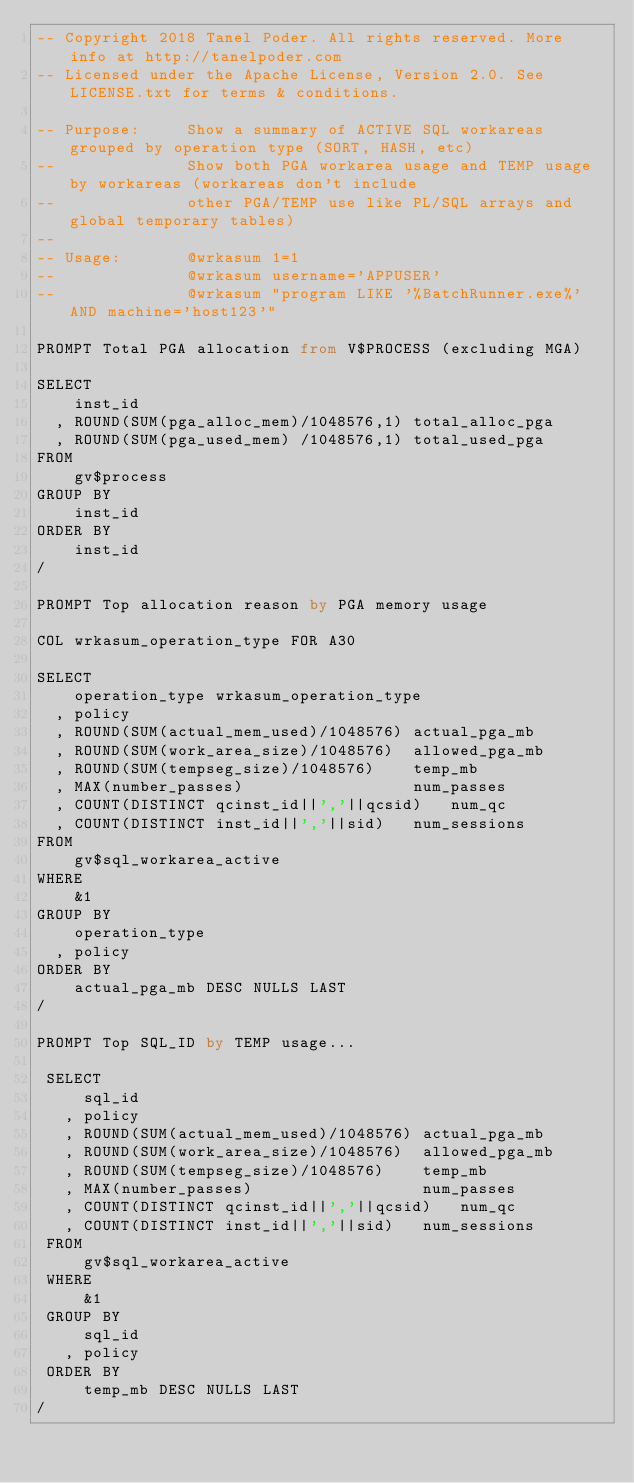Convert code to text. <code><loc_0><loc_0><loc_500><loc_500><_SQL_>-- Copyright 2018 Tanel Poder. All rights reserved. More info at http://tanelpoder.com
-- Licensed under the Apache License, Version 2.0. See LICENSE.txt for terms & conditions.

-- Purpose:     Show a summary of ACTIVE SQL workareas grouped by operation type (SORT, HASH, etc)
--              Show both PGA workarea usage and TEMP usage by workareas (workareas don't include
--              other PGA/TEMP use like PL/SQL arrays and global temporary tables)
--
-- Usage:       @wrkasum 1=1 
--              @wrkasum username='APPUSER'
--              @wrkasum "program LIKE '%BatchRunner.exe%' AND machine='host123'"

PROMPT Total PGA allocation from V$PROCESS (excluding MGA)

SELECT 
    inst_id
  , ROUND(SUM(pga_alloc_mem)/1048576,1) total_alloc_pga
  , ROUND(SUM(pga_used_mem) /1048576,1) total_used_pga
FROM
    gv$process
GROUP BY
    inst_id
ORDER BY
    inst_id
/

PROMPT Top allocation reason by PGA memory usage

COL wrkasum_operation_type FOR A30
 
SELECT
    operation_type wrkasum_operation_type
  , policy
  , ROUND(SUM(actual_mem_used)/1048576) actual_pga_mb
  , ROUND(SUM(work_area_size)/1048576)  allowed_pga_mb
  , ROUND(SUM(tempseg_size)/1048576)    temp_mb
  , MAX(number_passes)                  num_passes
  , COUNT(DISTINCT qcinst_id||','||qcsid)   num_qc
  , COUNT(DISTINCT inst_id||','||sid)   num_sessions
FROM
    gv$sql_workarea_active
WHERE
    &1
GROUP BY 
    operation_type
  , policy
ORDER BY 
    actual_pga_mb DESC NULLS LAST
/

PROMPT Top SQL_ID by TEMP usage...

 SELECT
     sql_id
   , policy
   , ROUND(SUM(actual_mem_used)/1048576) actual_pga_mb
   , ROUND(SUM(work_area_size)/1048576)  allowed_pga_mb
   , ROUND(SUM(tempseg_size)/1048576)    temp_mb
   , MAX(number_passes)                  num_passes
   , COUNT(DISTINCT qcinst_id||','||qcsid)   num_qc
   , COUNT(DISTINCT inst_id||','||sid)   num_sessions
 FROM
     gv$sql_workarea_active
 WHERE
     &1
 GROUP BY 
     sql_id
   , policy
 ORDER BY 
     temp_mb DESC NULLS LAST
/

</code> 